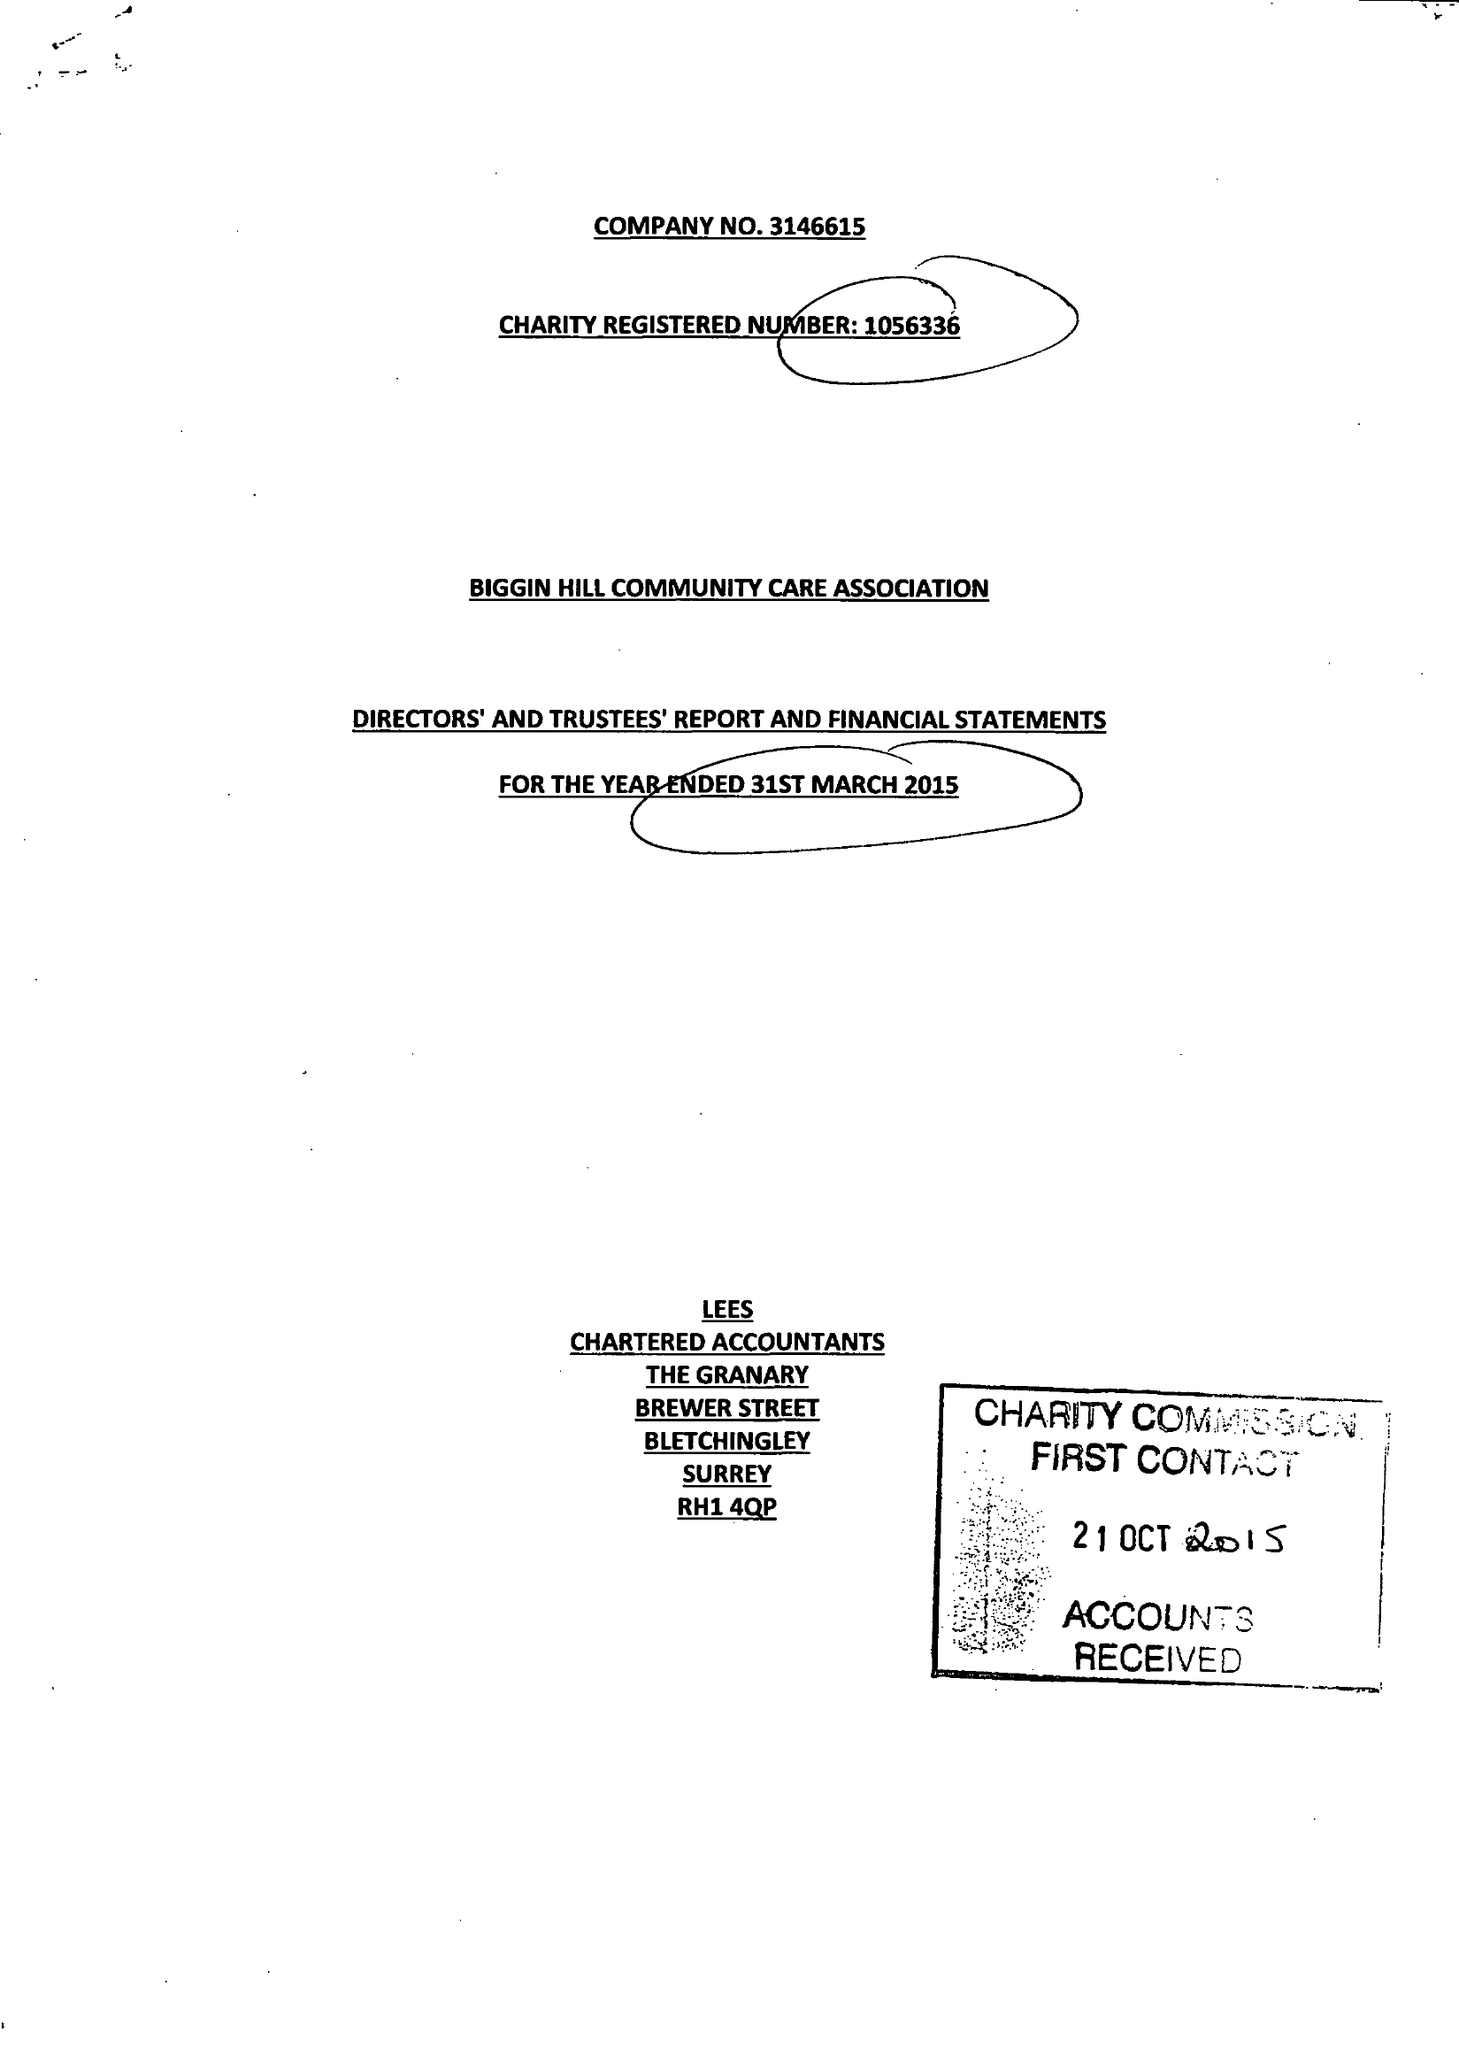What is the value for the address__street_line?
Answer the question using a single word or phrase. CHURCH ROAD 